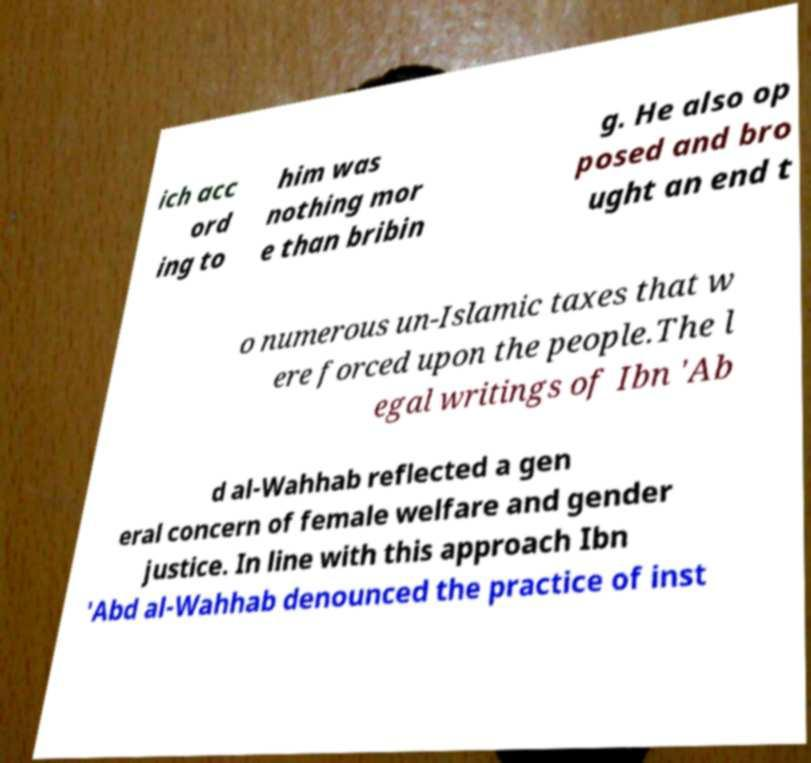What messages or text are displayed in this image? I need them in a readable, typed format. ich acc ord ing to him was nothing mor e than bribin g. He also op posed and bro ught an end t o numerous un-Islamic taxes that w ere forced upon the people.The l egal writings of Ibn 'Ab d al-Wahhab reflected a gen eral concern of female welfare and gender justice. In line with this approach Ibn 'Abd al-Wahhab denounced the practice of inst 